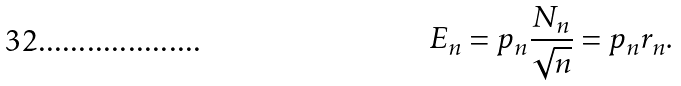Convert formula to latex. <formula><loc_0><loc_0><loc_500><loc_500>E _ { n } = p _ { n } \frac { N _ { n } } { \sqrt { n } } = p _ { n } r _ { n } .</formula> 